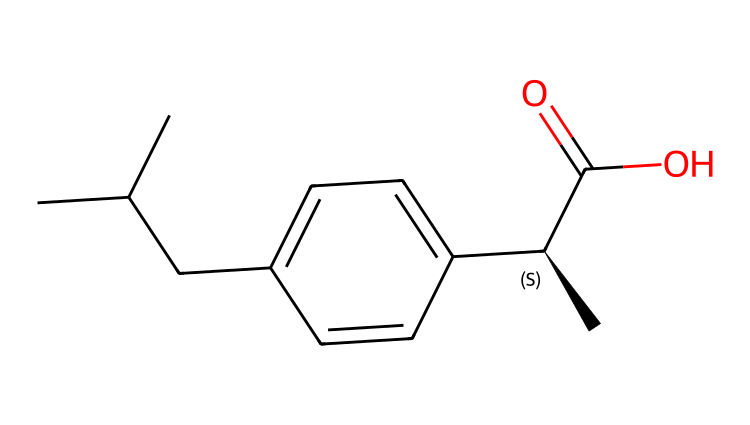What is the molecular formula for ibuprofen? To determine the molecular formula, we analyze the SMILES representation. The atoms in the SMILES include carbon (C), hydrogen (H), and oxygen (O). Counting the atoms gives us: 13 carbon atoms, 18 hydrogen atoms, and 2 oxygen atoms, leading to the molecular formula C13H18O2.
Answer: C13H18O2 How many chiral centers are present in ibuprofen? A chiral center typically has four different substituents. In the SMILES structure, we can identify one chiral carbon, which is indicated by the notation [C@H], meaning it's stereo-specific. Thus, there is one chiral center.
Answer: 1 What functional groups are present in ibuprofen? Looking at the SMILES structure, we identify the carboxylic acid group (C(=O)O) and an aromatic ring (ccccc). The presence of -COOH indicates a carboxylic acid, while the benzene structure indicates an aromatic compound. Therefore, the functional groups are carboxylic acid and aromatic ring.
Answer: carboxylic acid and aromatic ring What is the total number of carbon atoms in ibuprofen? By interpreting the SMILES representation, we count the number of carbon atoms depicted in the structure. Each "C" represents a carbon, and there are 13 occurrences. Hence, the total number of carbon atoms is 13.
Answer: 13 What type of drug classification does ibuprofen fall under? Ibuprofen is classified as a nonsteroidal anti-inflammatory drug (NSAID), which is evident from its structure and its functional groups. It is specifically known for its pain-relieving and anti-inflammatory properties.
Answer: nonsteroidal anti-inflammatory drug How many hydrogen atoms are bonded to the most substituted carbon in ibuprofen? Observing the structural representation, the most substituted carbon (the one with the chiral center) is bonded to one hydrogen atom, owing to the presence of three other substituents (a methyl group and two groups including the benzene ring and the –COOH).
Answer: 1 